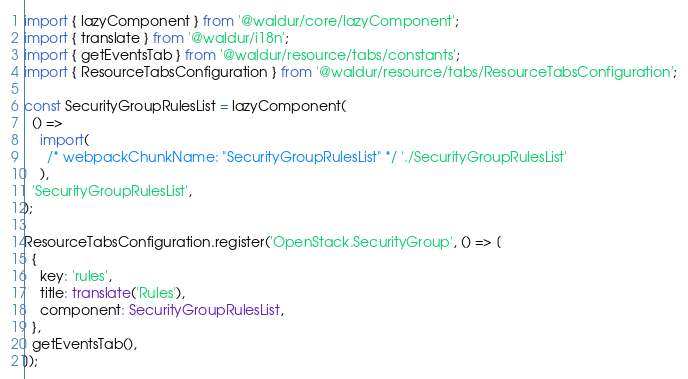Convert code to text. <code><loc_0><loc_0><loc_500><loc_500><_TypeScript_>import { lazyComponent } from '@waldur/core/lazyComponent';
import { translate } from '@waldur/i18n';
import { getEventsTab } from '@waldur/resource/tabs/constants';
import { ResourceTabsConfiguration } from '@waldur/resource/tabs/ResourceTabsConfiguration';

const SecurityGroupRulesList = lazyComponent(
  () =>
    import(
      /* webpackChunkName: "SecurityGroupRulesList" */ './SecurityGroupRulesList'
    ),
  'SecurityGroupRulesList',
);

ResourceTabsConfiguration.register('OpenStack.SecurityGroup', () => [
  {
    key: 'rules',
    title: translate('Rules'),
    component: SecurityGroupRulesList,
  },
  getEventsTab(),
]);
</code> 